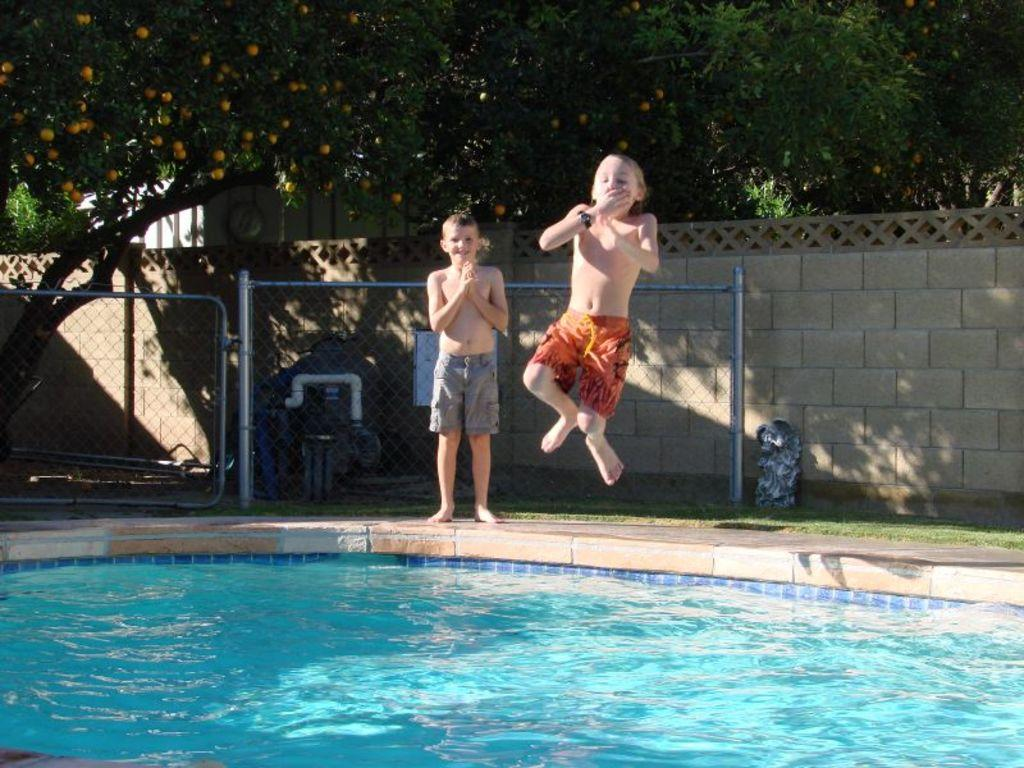What is visible in the image? Water, two children, fencing, grass, a wall, trees, and fruits on the trees are visible in the image. Can you describe the children in the image? There are two children in the front of the image. What can be seen in the background of the image? Fencing, grass, a wall, trees, and fruits on the trees are visible in the background of the image. What type of adjustment can be seen on the zinc in the image? There is no zinc or adjustment present in the image. How many ducks are swimming in the water in the image? There are no ducks visible in the water in the image. 